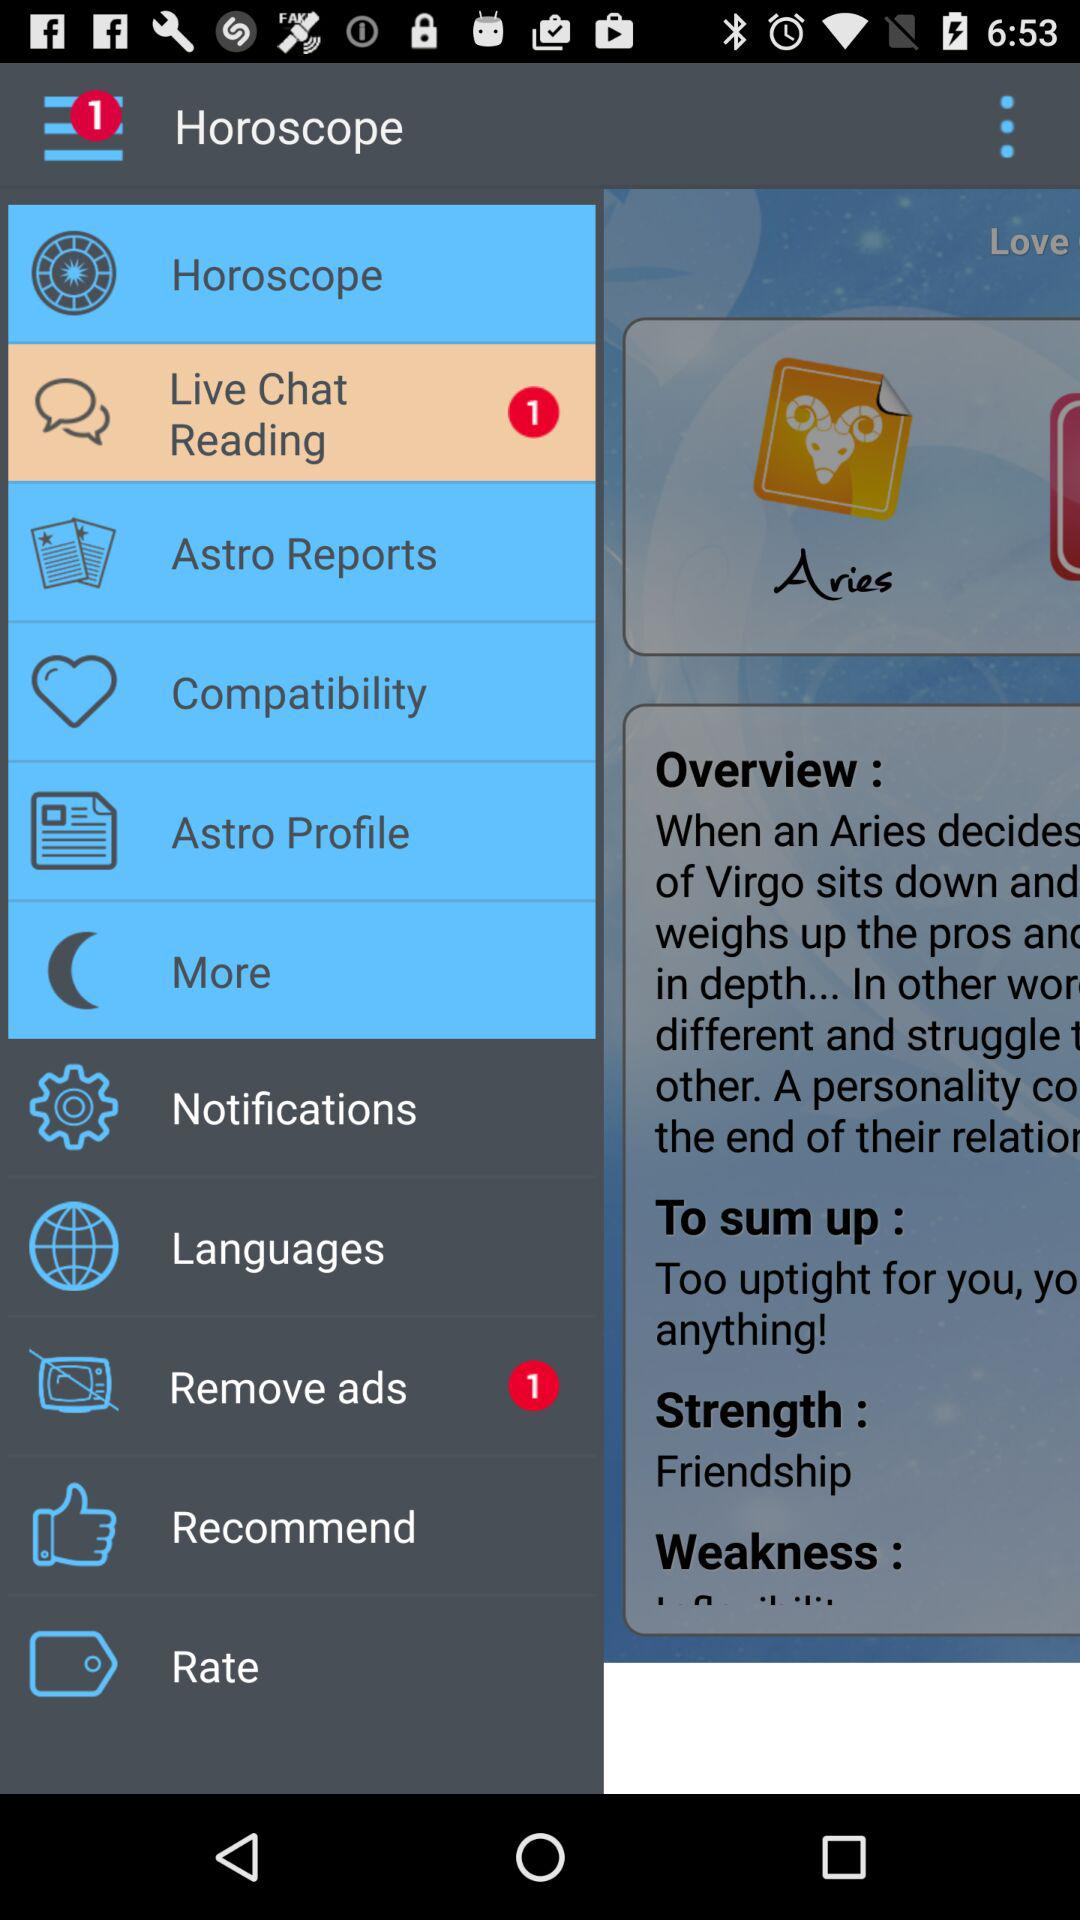What is the strength? The strength is "Friendship". 